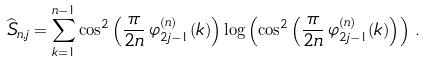<formula> <loc_0><loc_0><loc_500><loc_500>\widehat { S } _ { n , j } = \sum _ { k = 1 } ^ { n - 1 } \cos ^ { 2 } \left ( \frac { \pi } { 2 n } \, \varphi _ { 2 j - 1 } ^ { ( n ) } ( k ) \right ) \log \left ( \cos ^ { 2 } \left ( \frac { \pi } { 2 n } \, \varphi _ { 2 j - 1 } ^ { ( n ) } ( k ) \right ) \right ) \, .</formula> 